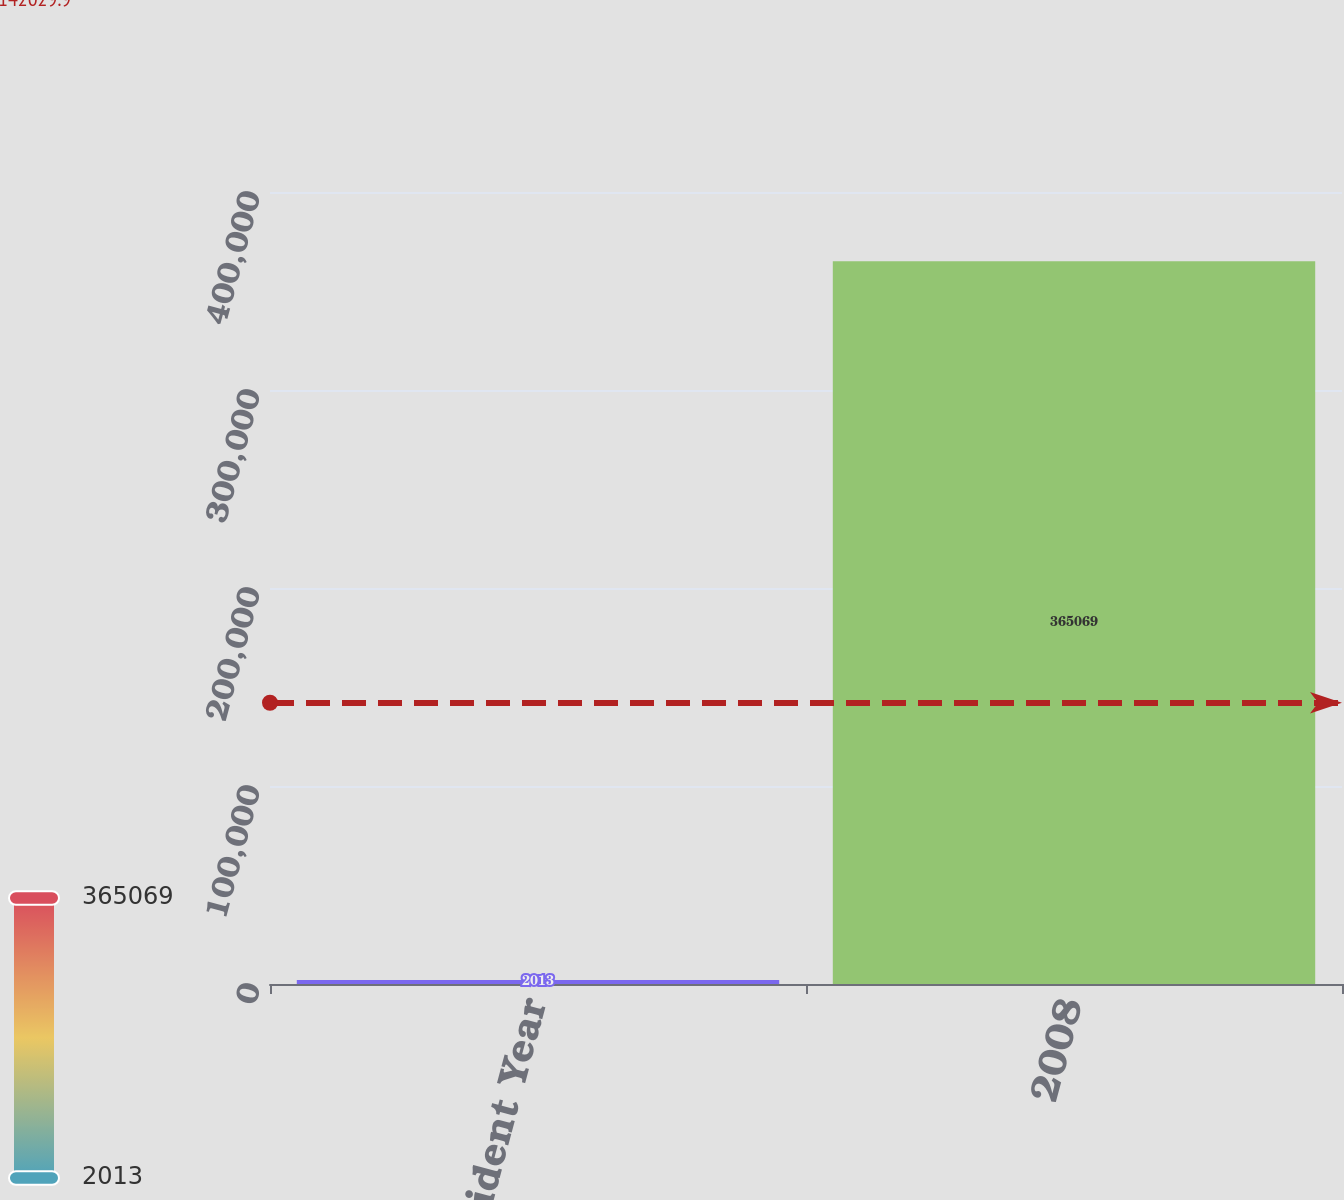Convert chart to OTSL. <chart><loc_0><loc_0><loc_500><loc_500><bar_chart><fcel>Accident Year<fcel>2008<nl><fcel>2013<fcel>365069<nl></chart> 